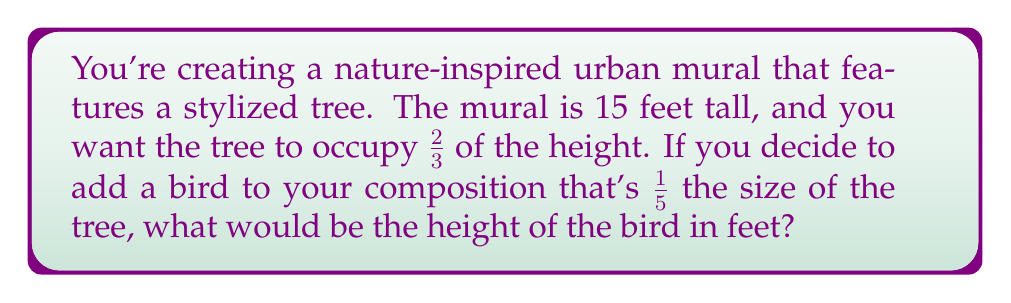What is the answer to this math problem? Let's break this problem down step by step:

1) First, we need to calculate the height of the tree:
   - The mural is 15 feet tall
   - The tree occupies 2/3 of the height
   - Tree height = $15 \times \frac{2}{3} = 10$ feet

2) Now, we know that the bird is 1/5 the size of the tree:
   - Bird height = Tree height $\times \frac{1}{5}$
   - Bird height = $10 \times \frac{1}{5} = 2$ feet

We can express this mathematically as:

$$\text{Bird height} = \text{Mural height} \times \frac{\text{Tree proportion}}{\text{Mural}} \times \frac{\text{Bird proportion}}{\text{Tree}}$$

$$\text{Bird height} = 15 \times \frac{2}{3} \times \frac{1}{5} = 15 \times \frac{2}{3} \times \frac{1}{5} = 2\text{ feet}$$

This calculation ensures that the proportions in your nature-inspired composition remain balanced and visually pleasing.
Answer: $2$ feet 